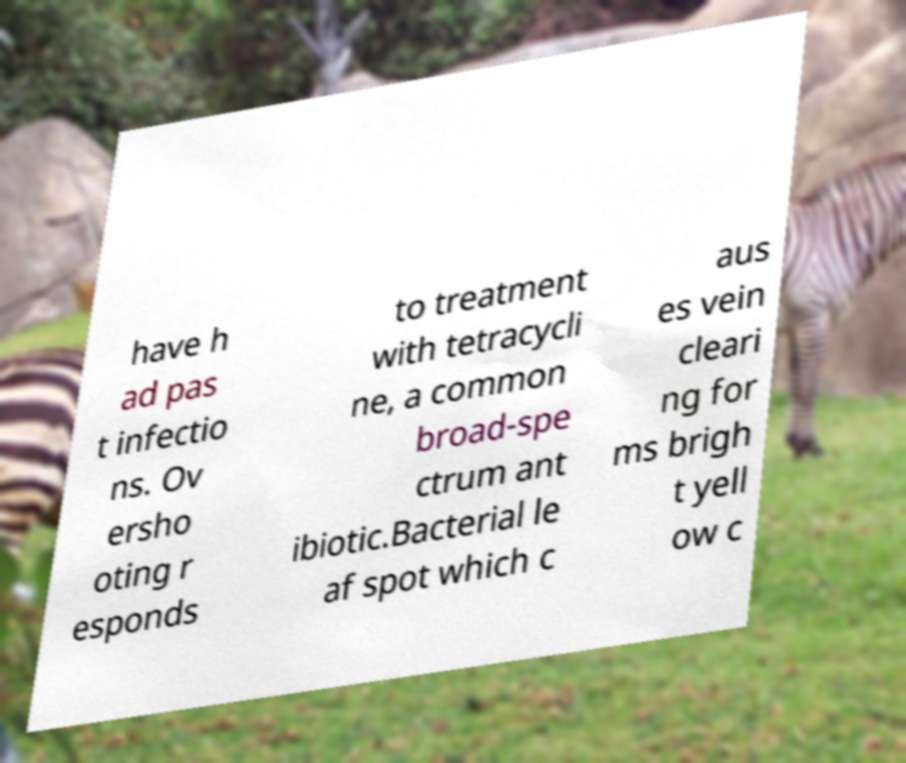Could you assist in decoding the text presented in this image and type it out clearly? have h ad pas t infectio ns. Ov ersho oting r esponds to treatment with tetracycli ne, a common broad-spe ctrum ant ibiotic.Bacterial le af spot which c aus es vein cleari ng for ms brigh t yell ow c 